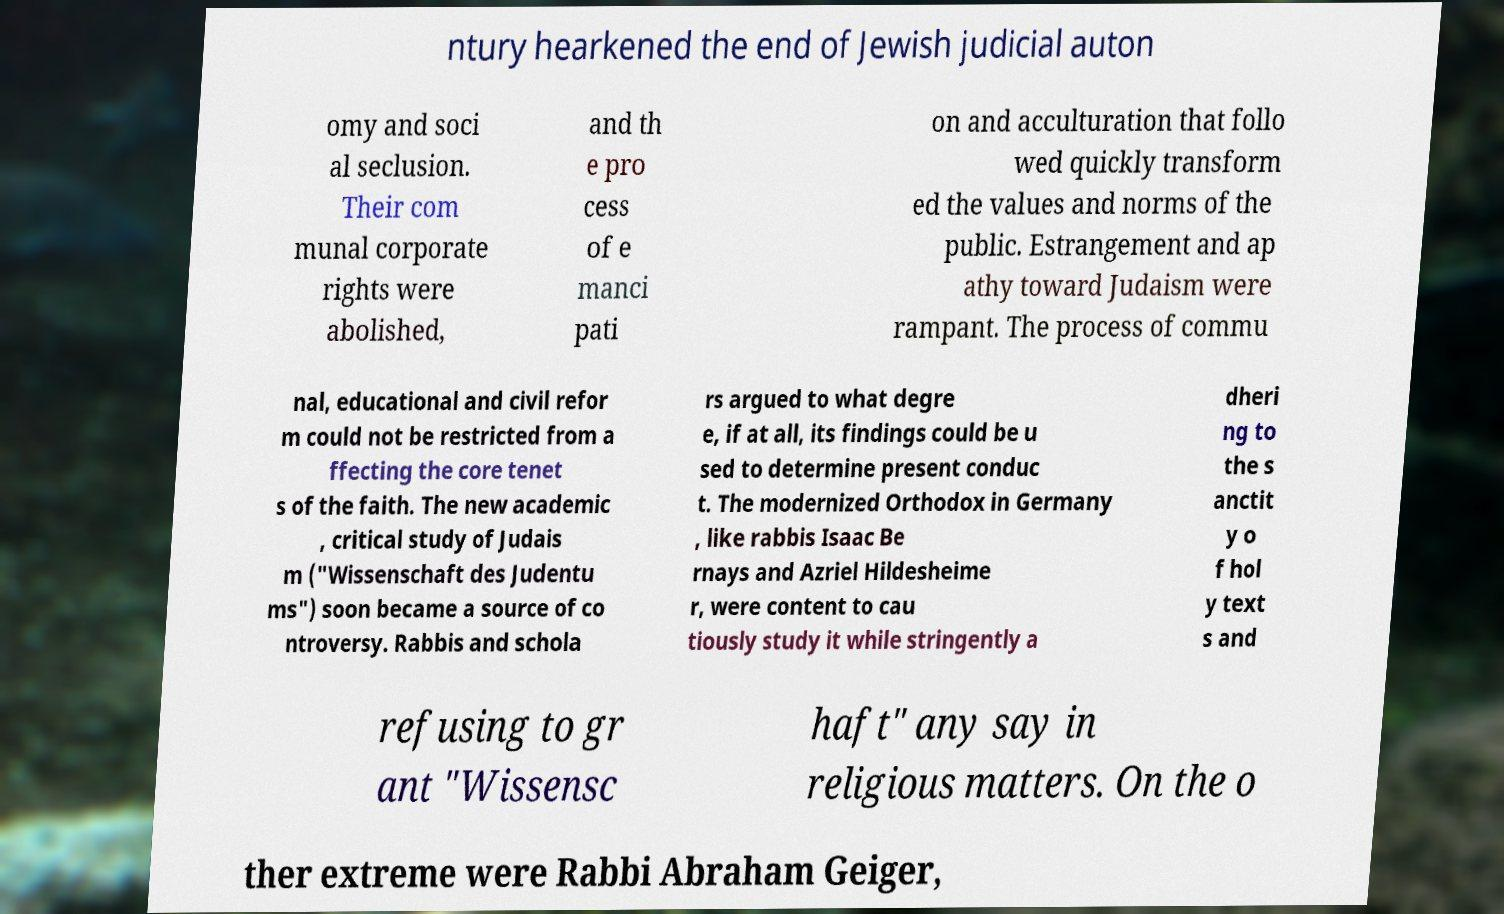Please identify and transcribe the text found in this image. ntury hearkened the end of Jewish judicial auton omy and soci al seclusion. Their com munal corporate rights were abolished, and th e pro cess of e manci pati on and acculturation that follo wed quickly transform ed the values and norms of the public. Estrangement and ap athy toward Judaism were rampant. The process of commu nal, educational and civil refor m could not be restricted from a ffecting the core tenet s of the faith. The new academic , critical study of Judais m ("Wissenschaft des Judentu ms") soon became a source of co ntroversy. Rabbis and schola rs argued to what degre e, if at all, its findings could be u sed to determine present conduc t. The modernized Orthodox in Germany , like rabbis Isaac Be rnays and Azriel Hildesheime r, were content to cau tiously study it while stringently a dheri ng to the s anctit y o f hol y text s and refusing to gr ant "Wissensc haft" any say in religious matters. On the o ther extreme were Rabbi Abraham Geiger, 